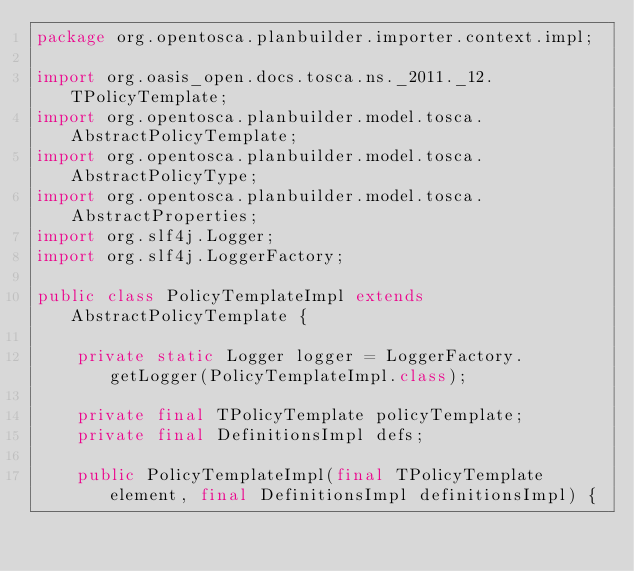Convert code to text. <code><loc_0><loc_0><loc_500><loc_500><_Java_>package org.opentosca.planbuilder.importer.context.impl;

import org.oasis_open.docs.tosca.ns._2011._12.TPolicyTemplate;
import org.opentosca.planbuilder.model.tosca.AbstractPolicyTemplate;
import org.opentosca.planbuilder.model.tosca.AbstractPolicyType;
import org.opentosca.planbuilder.model.tosca.AbstractProperties;
import org.slf4j.Logger;
import org.slf4j.LoggerFactory;

public class PolicyTemplateImpl extends AbstractPolicyTemplate {

    private static Logger logger = LoggerFactory.getLogger(PolicyTemplateImpl.class);

    private final TPolicyTemplate policyTemplate;
    private final DefinitionsImpl defs;

    public PolicyTemplateImpl(final TPolicyTemplate element, final DefinitionsImpl definitionsImpl) {</code> 